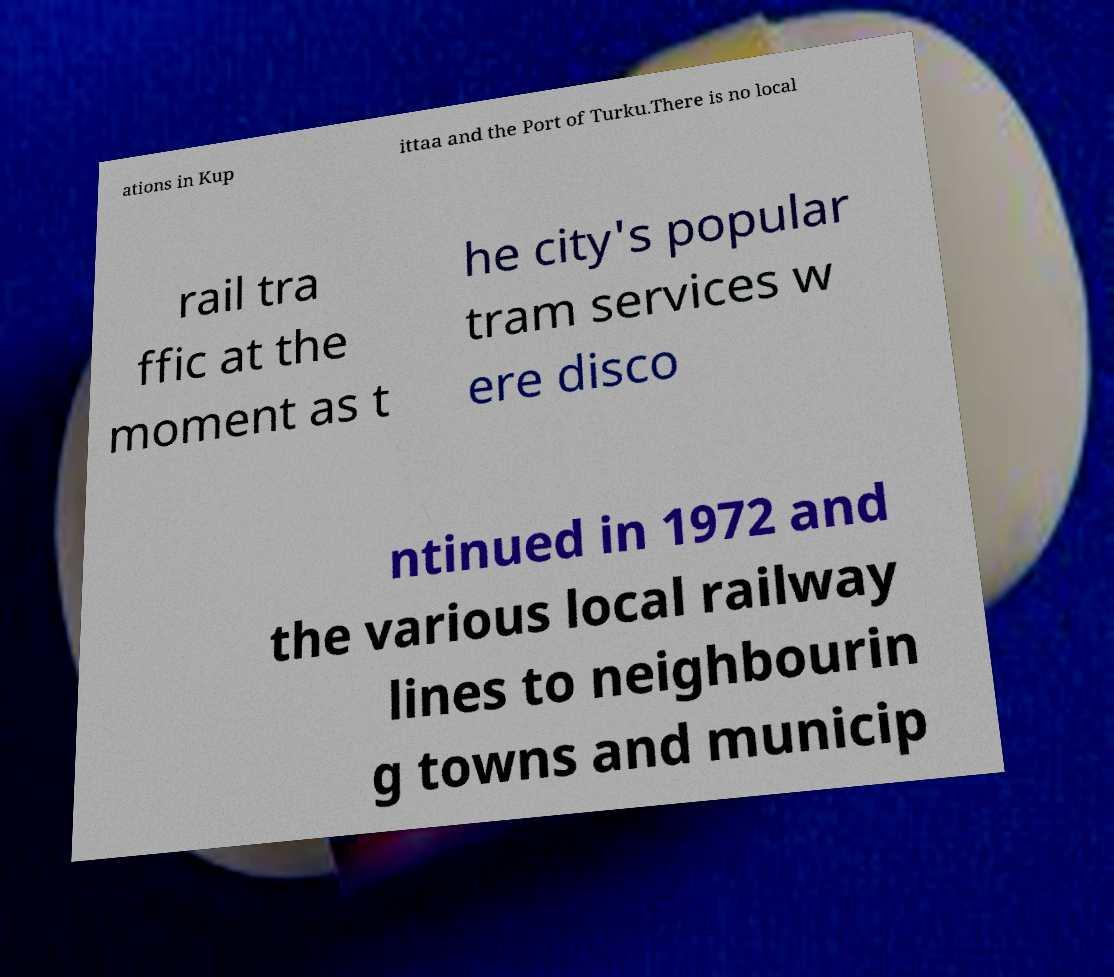Please identify and transcribe the text found in this image. ations in Kup ittaa and the Port of Turku.There is no local rail tra ffic at the moment as t he city's popular tram services w ere disco ntinued in 1972 and the various local railway lines to neighbourin g towns and municip 